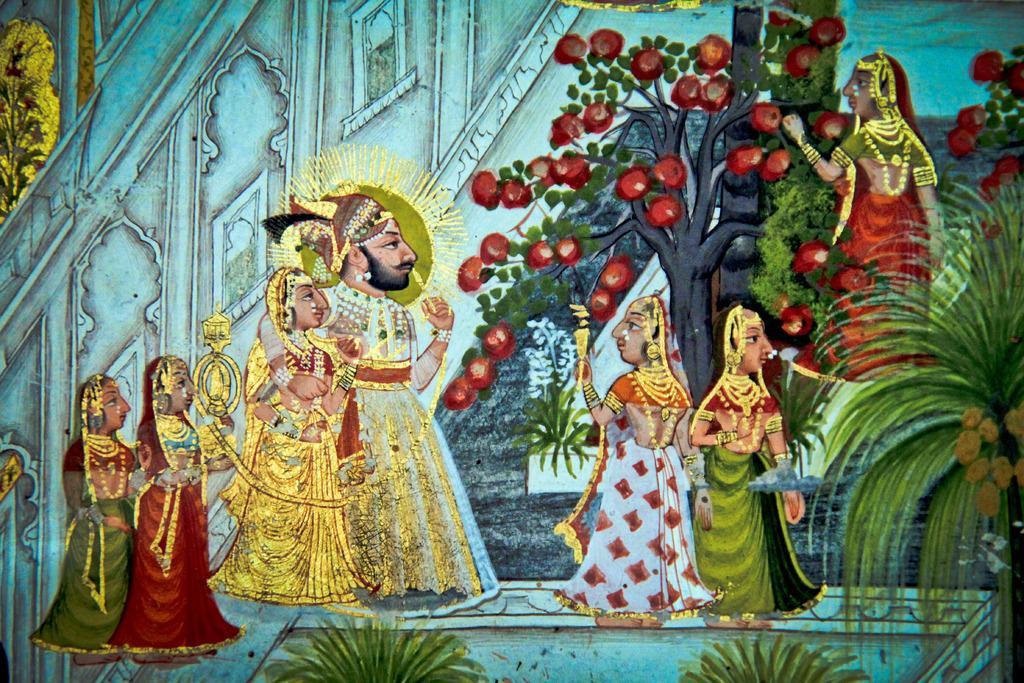In one or two sentences, can you explain what this image depicts? In the image we can see painting. In the painting,we can see few people were standing. And we can see trees,building and wall. 